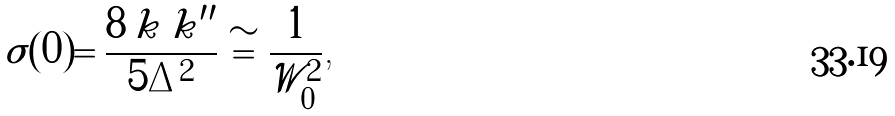Convert formula to latex. <formula><loc_0><loc_0><loc_500><loc_500>\sigma ( 0 ) = \frac { 8 \, k \, k ^ { \prime \prime } } { 5 \Delta ^ { 2 } } \cong \frac { 1 } { \mathcal { W } ^ { 2 } _ { 0 } } \text {,}</formula> 